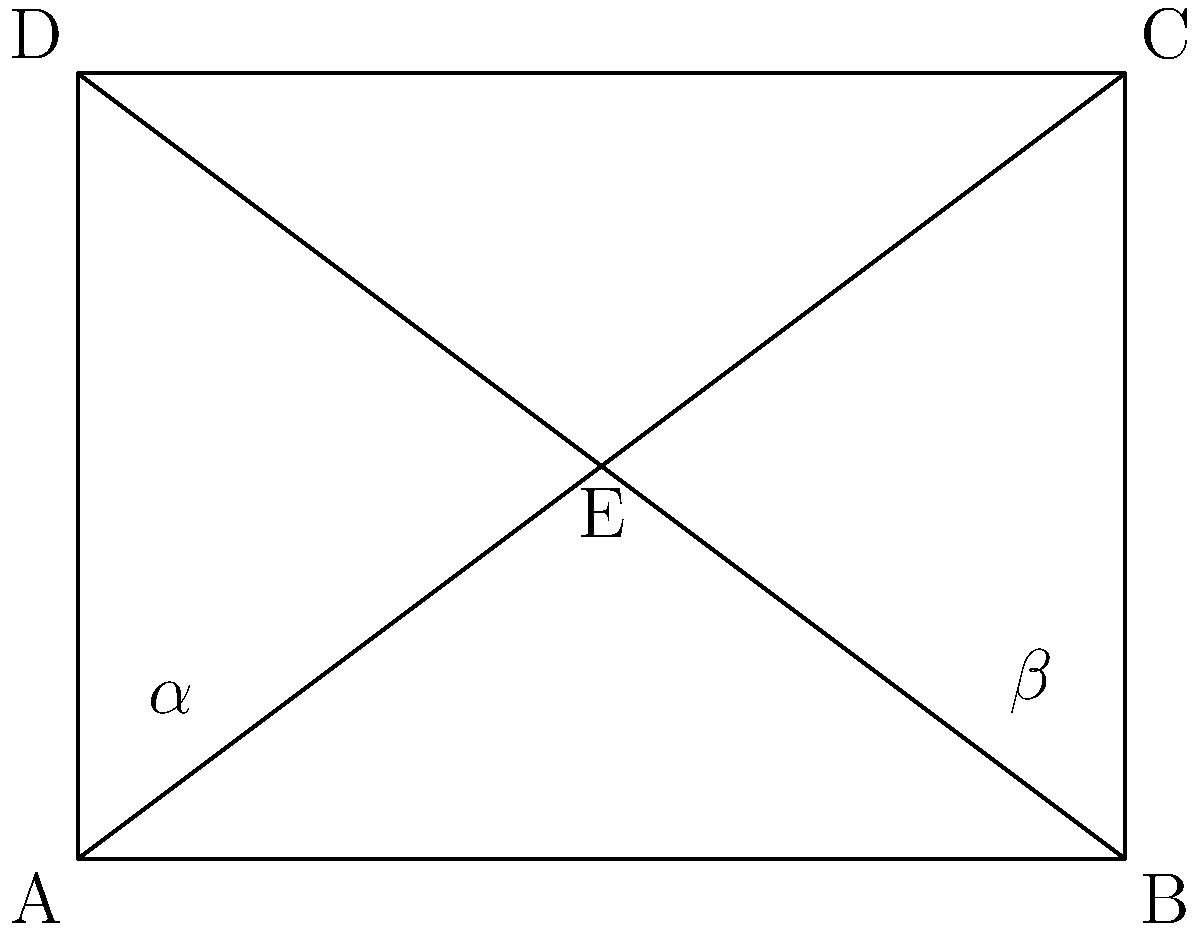В архитектурной фотографии часто используется техника съемки с двумя точками схода. На рисунке представлен вид сверху на здание, где точка E - позиция фотографа. Если угол $\alpha$ равен 30°, чему равен угол $\beta$? Чтобы решить эту задачу, выполним следующие шаги:

1) В прямоугольнике ABCD, диагонали AC и BD пересекаются в точке E, которая является позицией фотографа.

2) Треугольники AEB и DEC являются подобными, так как:
   - Углы BAE и CDE равны (вертикальные углы)
   - Углы ABE и DCE равны (вертикальные углы)
   - Углы AEB и DEC равны (вертикальные углы)

3) Из подобия треугольников следует, что $\angle AEB = \angle DEC$

4) Сумма углов в треугольнике AEB равна 180°:
   $\alpha + \beta + \angle AEB = 180°$

5) Аналогично для треугольника DEC:
   $\angle DEC + \beta + \alpha = 180°$

6) Так как $\angle AEB = \angle DEC$, можем записать:
   $2(\alpha + \beta) = 180°$
   $\alpha + \beta = 90°$

7) Зная, что $\alpha = 30°$, находим $\beta$:
   $30° + \beta = 90°$
   $\beta = 60°$

Таким образом, если угол $\alpha$ равен 30°, то угол $\beta$ будет равен 60°.
Answer: 60° 